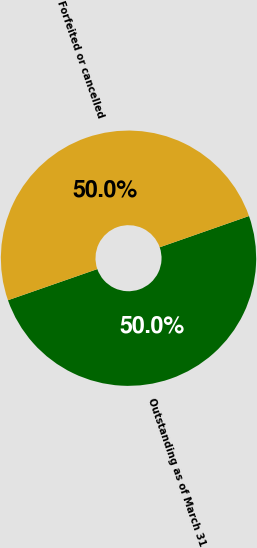<chart> <loc_0><loc_0><loc_500><loc_500><pie_chart><fcel>Outstanding as of March 31<fcel>Forfeited or cancelled<nl><fcel>50.02%<fcel>49.98%<nl></chart> 